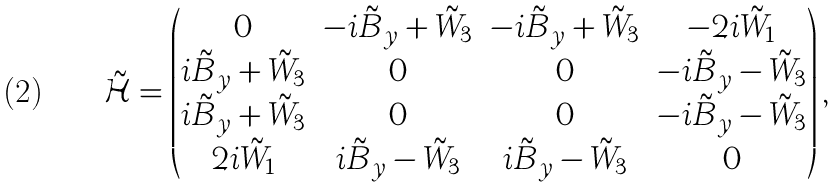Convert formula to latex. <formula><loc_0><loc_0><loc_500><loc_500>\mathcal { \tilde { H } } = \begin{pmatrix} 0 & - i \tilde { B } _ { y } + \tilde { W } _ { 3 } & - i \tilde { B } _ { y } + \tilde { W } _ { 3 } & - 2 i \tilde { W } _ { 1 } \\ i \tilde { B } _ { y } + \tilde { W } _ { 3 } & 0 & 0 & - i \tilde { B } _ { y } - \tilde { W } _ { 3 } \\ i \tilde { B } _ { y } + \tilde { W } _ { 3 } & 0 & 0 & - i \tilde { B } _ { y } - \tilde { W } _ { 3 } \\ 2 i \tilde { W } _ { 1 } & i \tilde { B } _ { y } - \tilde { W } _ { 3 } & i \tilde { B } _ { y } - \tilde { W } _ { 3 } & 0 \end{pmatrix} ,</formula> 